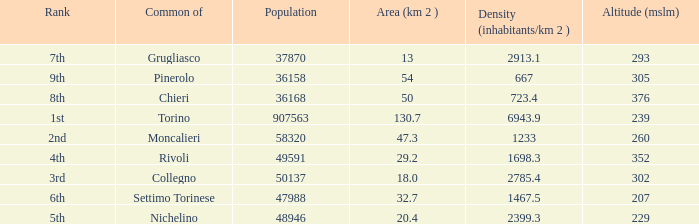How many altitudes does the common with an area of 130.7 km^2 have? 1.0. 